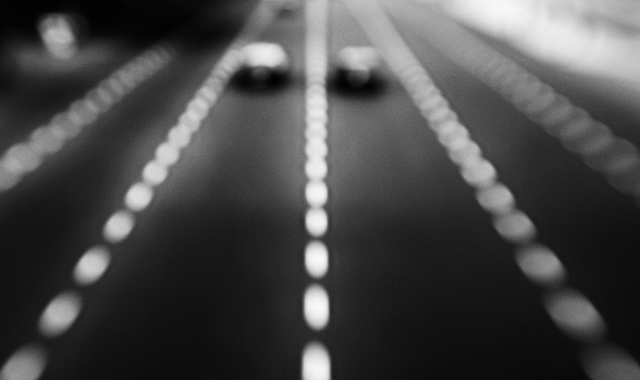How might the use of blur in this photo influence our perception of speed or motion? The use of intentional blur in photographs typically suggests rapid motion or speed. It creates a visual illusion that objects are moving very quickly. In this image, the streaks of light and undistinguishable details of the cars accentuate the feeling of high speed, as if the viewer is catching just a glimpse of the action while it whizzes by. 